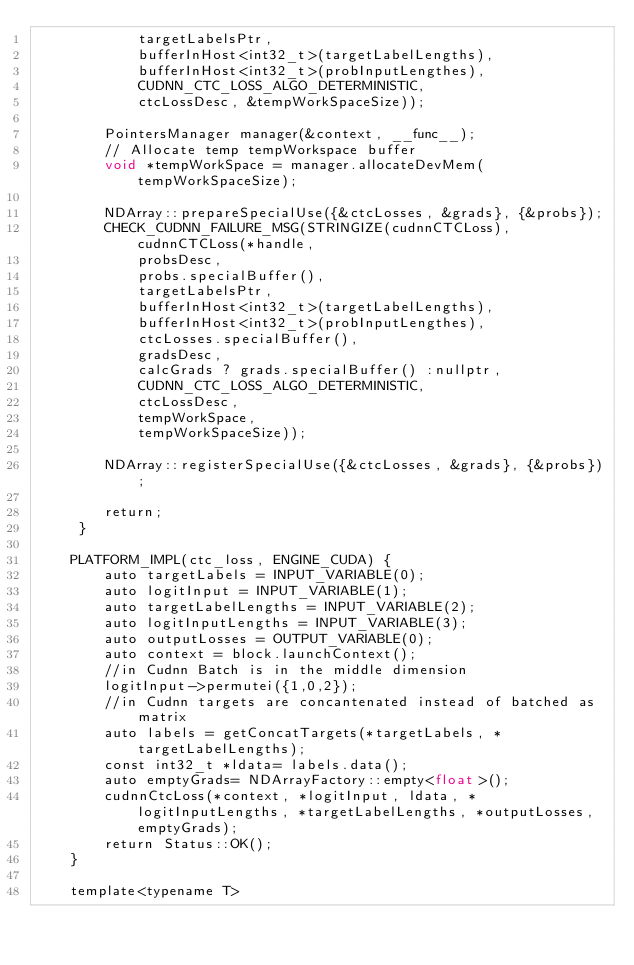Convert code to text. <code><loc_0><loc_0><loc_500><loc_500><_Cuda_>            targetLabelsPtr,
            bufferInHost<int32_t>(targetLabelLengths),
            bufferInHost<int32_t>(probInputLengthes),
            CUDNN_CTC_LOSS_ALGO_DETERMINISTIC,
            ctcLossDesc, &tempWorkSpaceSize));

        PointersManager manager(&context, __func__);
        // Allocate temp tempWorkspace buffer
        void *tempWorkSpace = manager.allocateDevMem(tempWorkSpaceSize);

        NDArray::prepareSpecialUse({&ctcLosses, &grads}, {&probs});
        CHECK_CUDNN_FAILURE_MSG(STRINGIZE(cudnnCTCLoss), cudnnCTCLoss(*handle,
            probsDesc,
            probs.specialBuffer(),
            targetLabelsPtr,
            bufferInHost<int32_t>(targetLabelLengths),
            bufferInHost<int32_t>(probInputLengthes),
            ctcLosses.specialBuffer(),
            gradsDesc,
            calcGrads ? grads.specialBuffer() :nullptr,
            CUDNN_CTC_LOSS_ALGO_DETERMINISTIC,
            ctcLossDesc,
            tempWorkSpace,
            tempWorkSpaceSize));

        NDArray::registerSpecialUse({&ctcLosses, &grads}, {&probs});

        return;
     }

    PLATFORM_IMPL(ctc_loss, ENGINE_CUDA) {
        auto targetLabels = INPUT_VARIABLE(0);
        auto logitInput = INPUT_VARIABLE(1);
        auto targetLabelLengths = INPUT_VARIABLE(2);
        auto logitInputLengths = INPUT_VARIABLE(3);
        auto outputLosses = OUTPUT_VARIABLE(0);
        auto context = block.launchContext();
        //in Cudnn Batch is in the middle dimension
        logitInput->permutei({1,0,2});
        //in Cudnn targets are concantenated instead of batched as matrix
        auto labels = getConcatTargets(*targetLabels, *targetLabelLengths);
        const int32_t *ldata= labels.data();
        auto emptyGrads= NDArrayFactory::empty<float>();
        cudnnCtcLoss(*context, *logitInput, ldata, *logitInputLengths, *targetLabelLengths, *outputLosses, emptyGrads);
        return Status::OK();
    }

    template<typename T></code> 